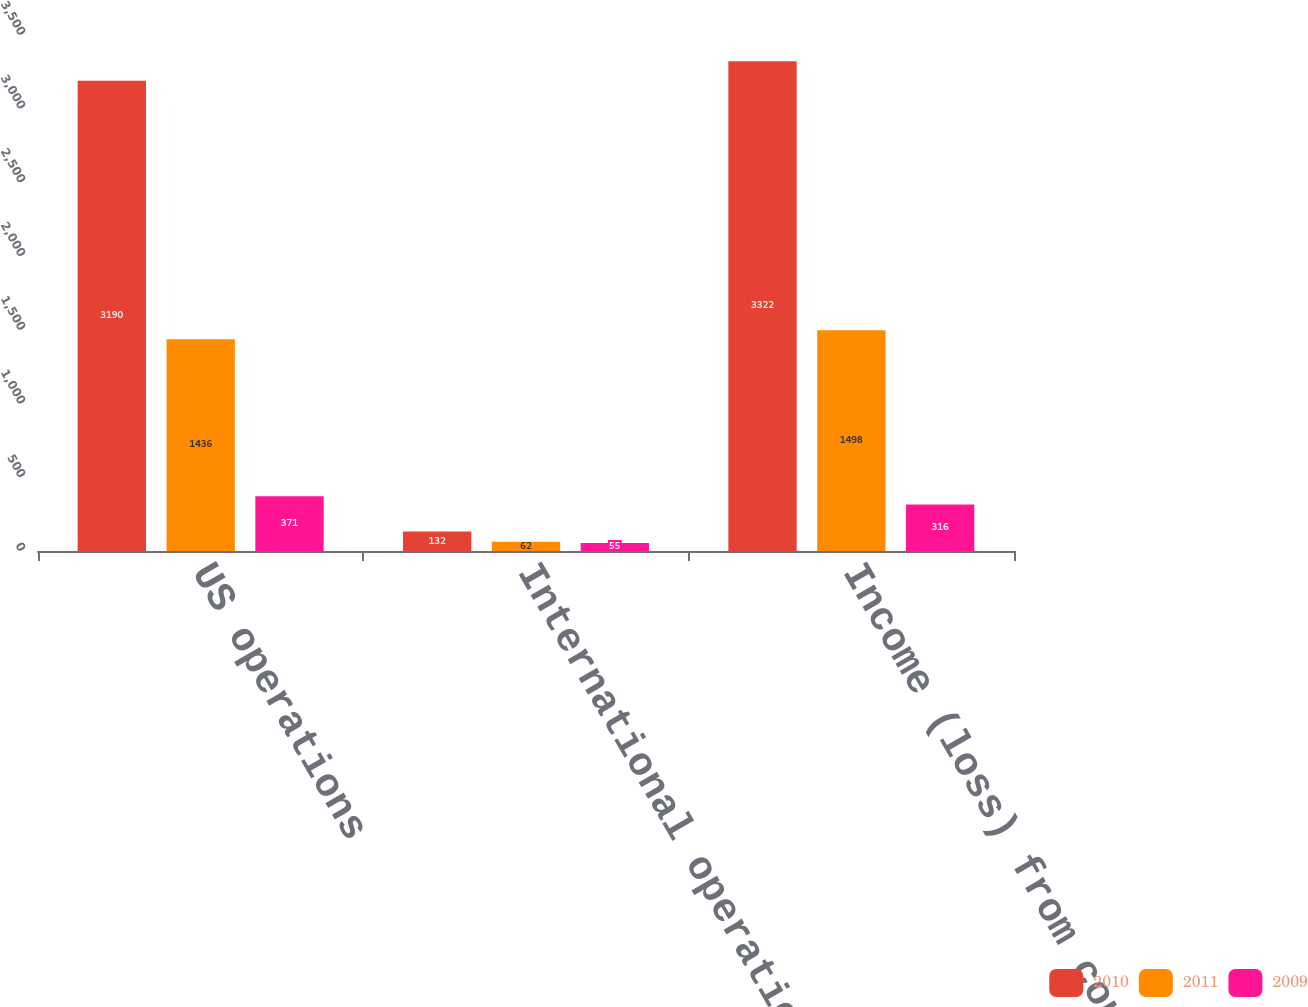Convert chart. <chart><loc_0><loc_0><loc_500><loc_500><stacked_bar_chart><ecel><fcel>US operations<fcel>International operations<fcel>Income (loss) from continuing<nl><fcel>2010<fcel>3190<fcel>132<fcel>3322<nl><fcel>2011<fcel>1436<fcel>62<fcel>1498<nl><fcel>2009<fcel>371<fcel>55<fcel>316<nl></chart> 